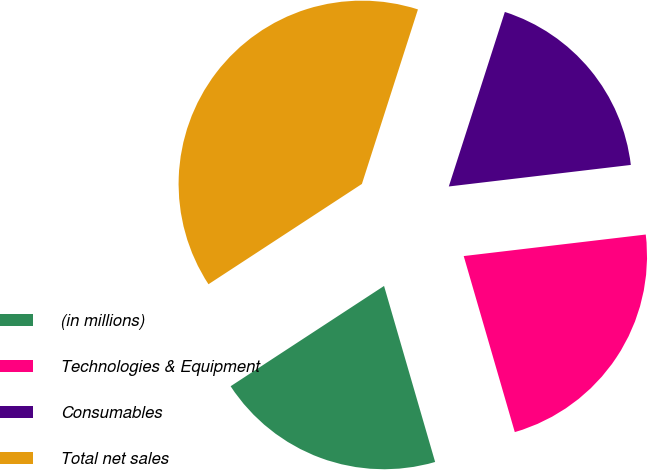<chart> <loc_0><loc_0><loc_500><loc_500><pie_chart><fcel>(in millions)<fcel>Technologies & Equipment<fcel>Consumables<fcel>Total net sales<nl><fcel>20.28%<fcel>22.38%<fcel>18.18%<fcel>39.16%<nl></chart> 